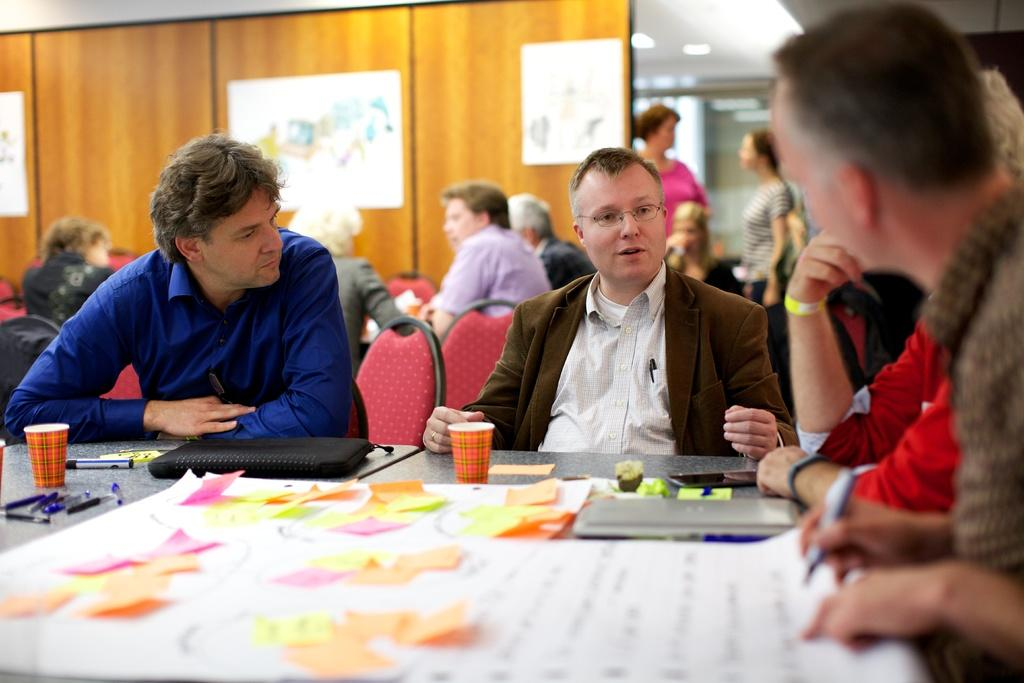What are the people in the image doing? The persons sitting on chairs near a table suggest they might be engaged in a meeting or discussion. What objects can be seen on the table? Cups, pens, charts, and laptops are present on the table. What material is the wall in the background made of? The wall in the background is made of wood. What type of hair can be seen on the vessel in the image? There is no vessel or hair present in the image. How is the bait being used in the image? There is no bait present in the image. 